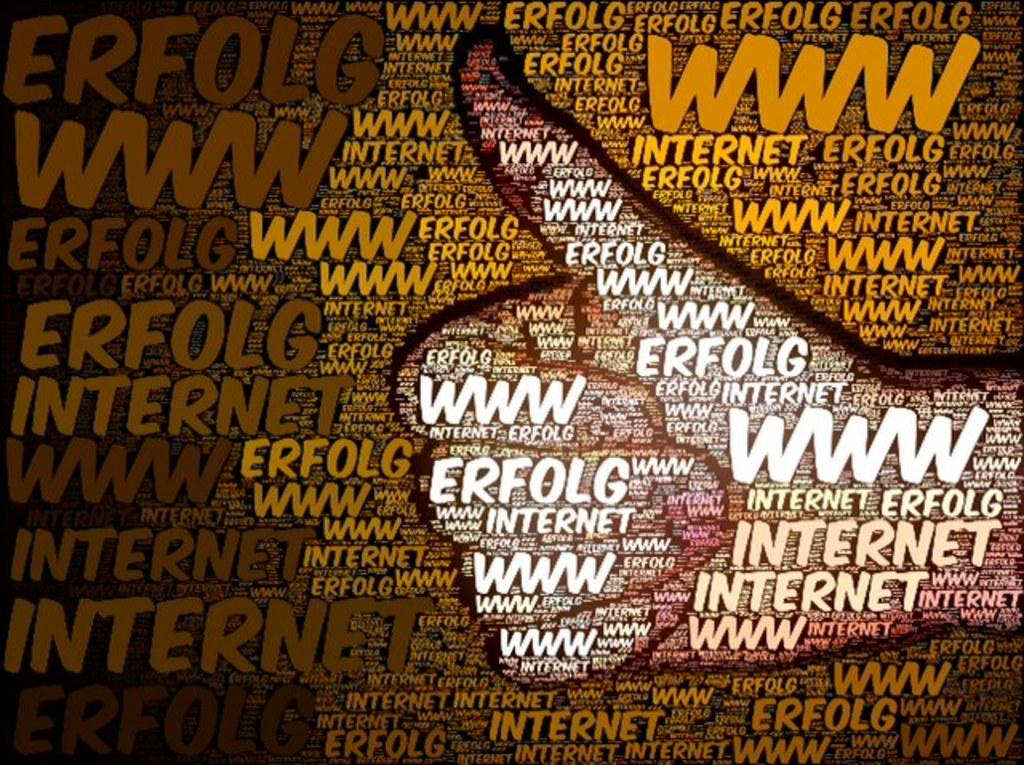<image>
Describe the image concisely. a bunch of words including www and a thumb 